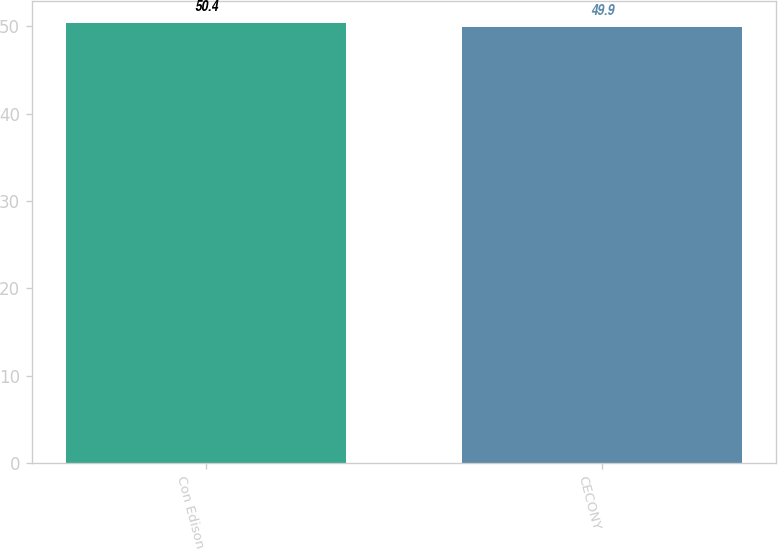Convert chart. <chart><loc_0><loc_0><loc_500><loc_500><bar_chart><fcel>Con Edison<fcel>CECONY<nl><fcel>50.4<fcel>49.9<nl></chart> 